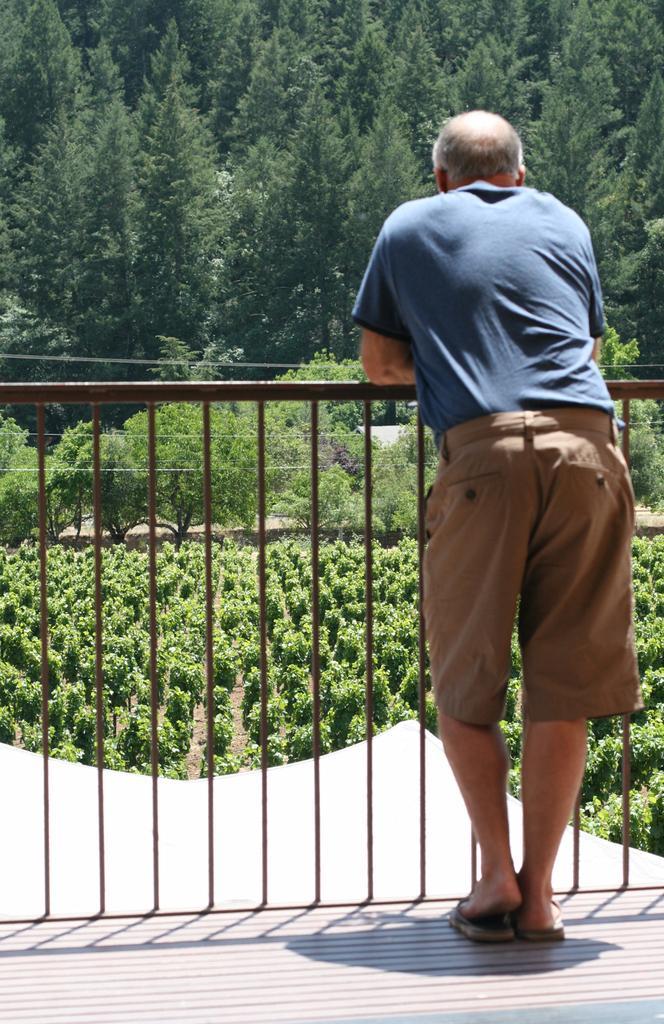Can you describe this image briefly? In the foreground of the image there is a person standing. There is a railing. In the background of the image there are trees, plants. At the bottom of the image there is floor. 